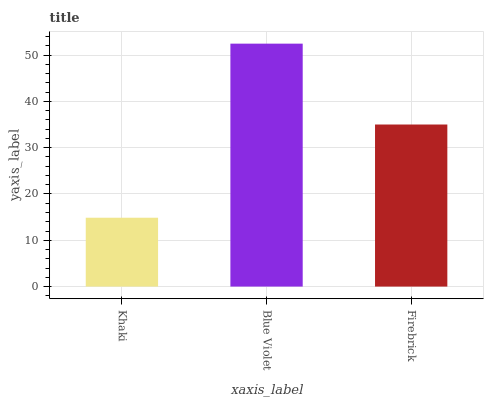Is Khaki the minimum?
Answer yes or no. Yes. Is Blue Violet the maximum?
Answer yes or no. Yes. Is Firebrick the minimum?
Answer yes or no. No. Is Firebrick the maximum?
Answer yes or no. No. Is Blue Violet greater than Firebrick?
Answer yes or no. Yes. Is Firebrick less than Blue Violet?
Answer yes or no. Yes. Is Firebrick greater than Blue Violet?
Answer yes or no. No. Is Blue Violet less than Firebrick?
Answer yes or no. No. Is Firebrick the high median?
Answer yes or no. Yes. Is Firebrick the low median?
Answer yes or no. Yes. Is Blue Violet the high median?
Answer yes or no. No. Is Khaki the low median?
Answer yes or no. No. 